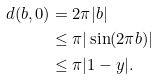Convert formula to latex. <formula><loc_0><loc_0><loc_500><loc_500>d ( b , 0 ) & = 2 \pi | b | \\ & \leq \pi | \sin ( 2 \pi b ) | \\ & \leq \pi | 1 - y | .</formula> 